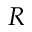Convert formula to latex. <formula><loc_0><loc_0><loc_500><loc_500>R</formula> 